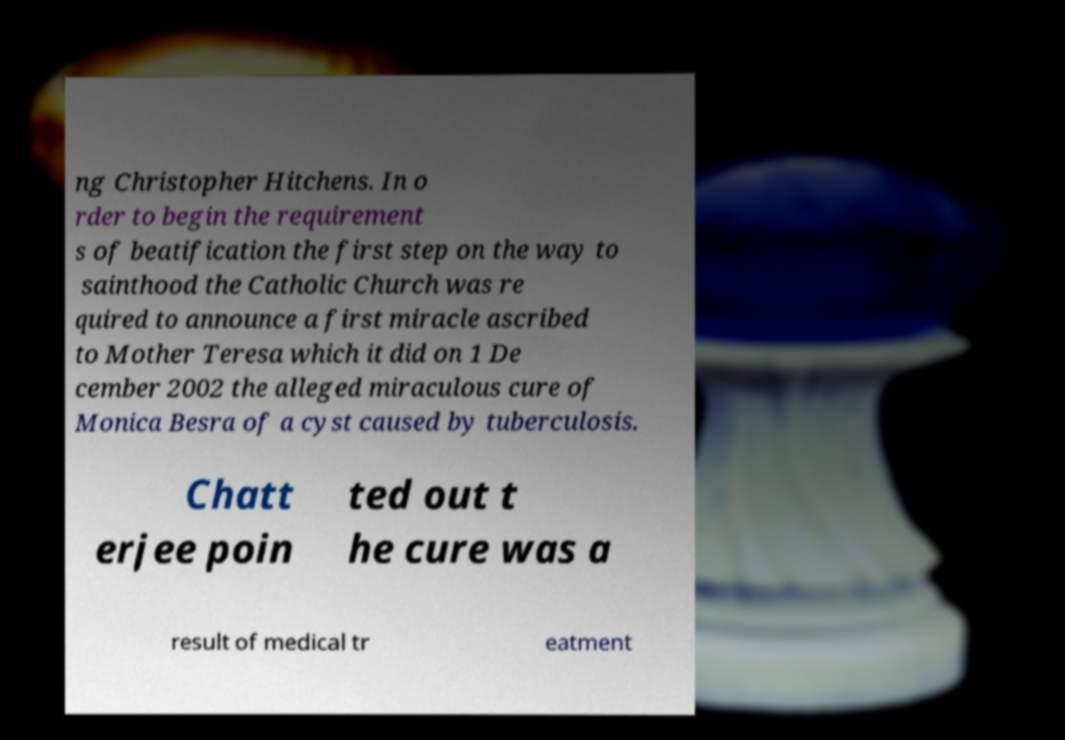What messages or text are displayed in this image? I need them in a readable, typed format. ng Christopher Hitchens. In o rder to begin the requirement s of beatification the first step on the way to sainthood the Catholic Church was re quired to announce a first miracle ascribed to Mother Teresa which it did on 1 De cember 2002 the alleged miraculous cure of Monica Besra of a cyst caused by tuberculosis. Chatt erjee poin ted out t he cure was a result of medical tr eatment 